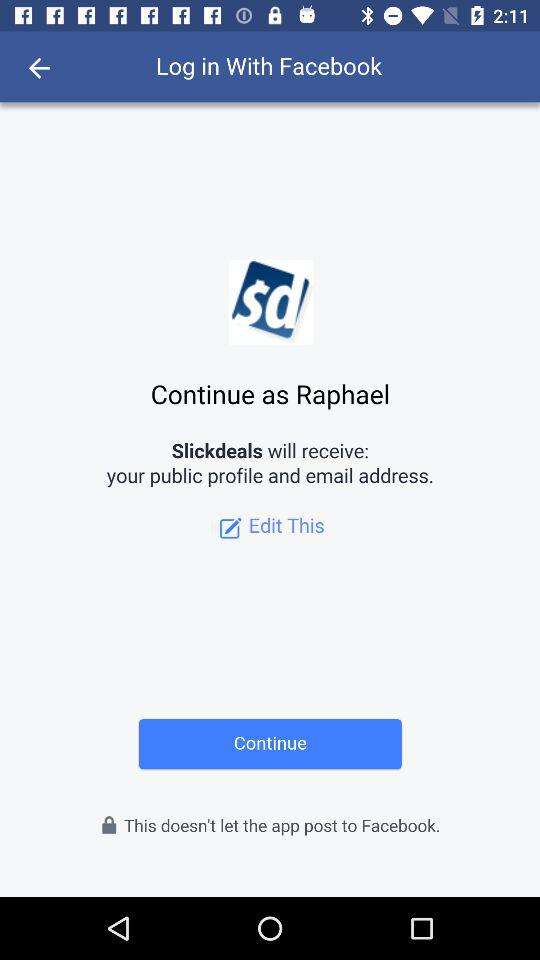What information will Slickdeals receive? Slickdeals will receive your public profile and email address. 